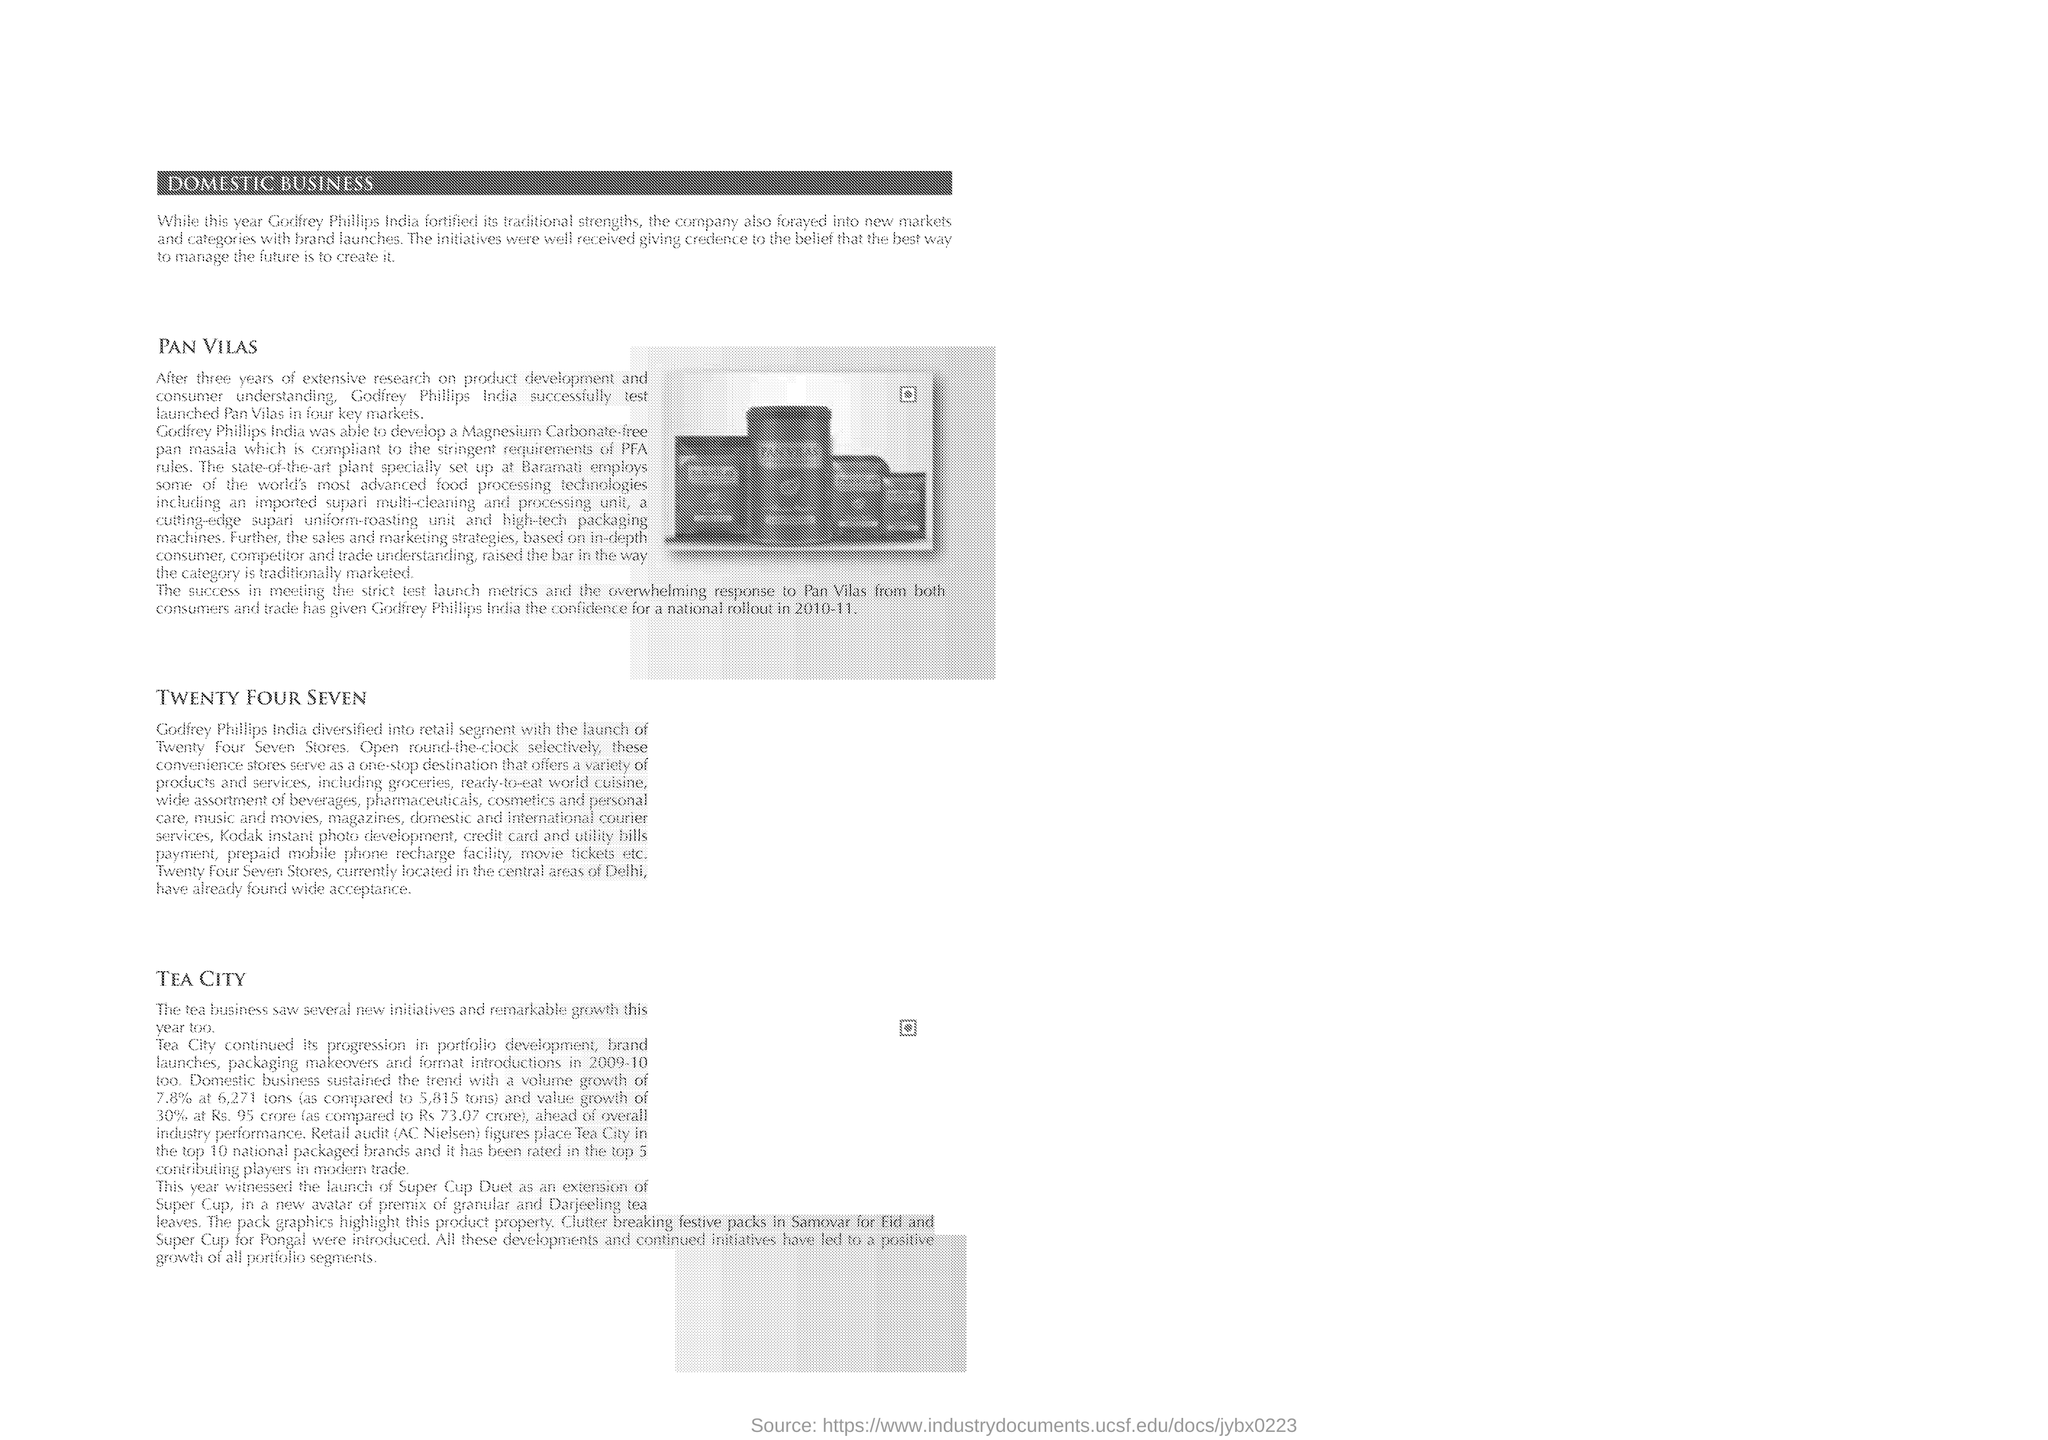Identify some key points in this picture. In 2010-11, Godfrey Phillips India gained confidence for a national rollout as a result of its successful trade. Godfrey Phillips India launched Pan Vilas in four key markets after conducting extensive testing. Which convenience store was the one-stop destination that offered a variety of products and services? 